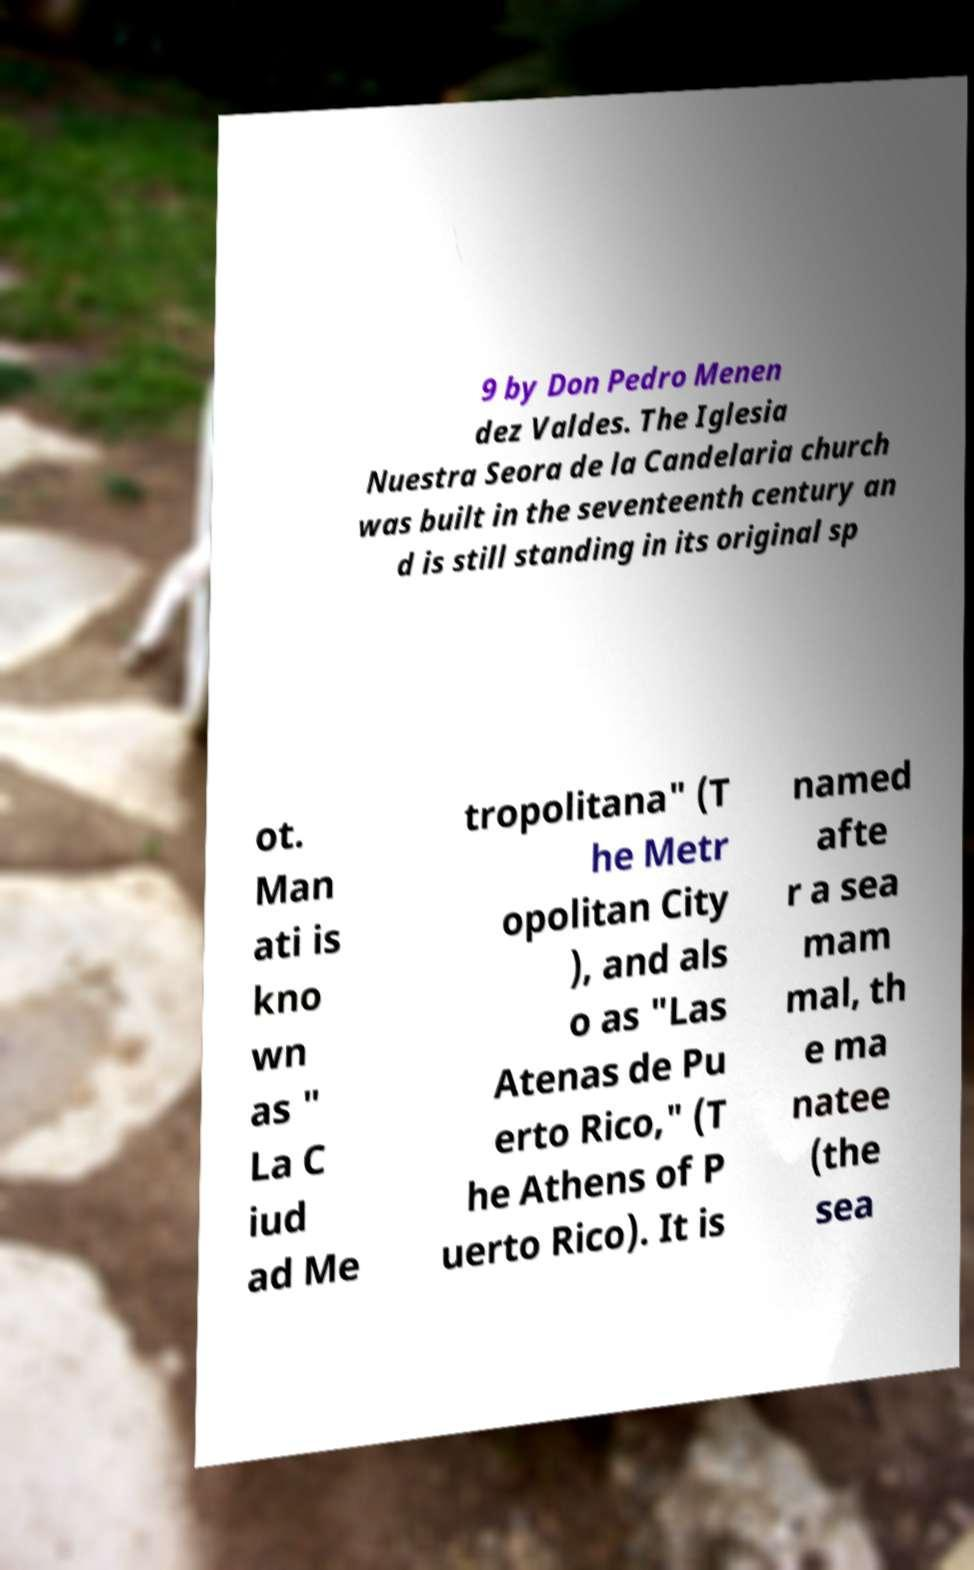Could you extract and type out the text from this image? 9 by Don Pedro Menen dez Valdes. The Iglesia Nuestra Seora de la Candelaria church was built in the seventeenth century an d is still standing in its original sp ot. Man ati is kno wn as " La C iud ad Me tropolitana" (T he Metr opolitan City ), and als o as "Las Atenas de Pu erto Rico," (T he Athens of P uerto Rico). It is named afte r a sea mam mal, th e ma natee (the sea 